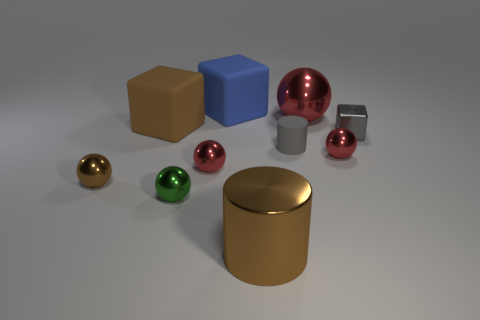What material is the green thing that is the same shape as the big red metallic thing?
Provide a succinct answer. Metal. There is a block that is both to the right of the green shiny thing and in front of the big blue rubber block; what is its color?
Offer a very short reply. Gray. The matte cylinder is what color?
Offer a very short reply. Gray. There is a cube that is the same color as the matte cylinder; what is it made of?
Your answer should be very brief. Metal. Is there another blue rubber thing of the same shape as the big blue thing?
Your answer should be compact. No. What size is the brown metal thing in front of the brown metallic ball?
Ensure brevity in your answer.  Large. There is a sphere that is the same size as the blue block; what material is it?
Your response must be concise. Metal. Is the number of rubber objects greater than the number of big shiny balls?
Your answer should be compact. Yes. What is the size of the brown object behind the small red shiny object right of the large red thing?
Offer a terse response. Large. There is a brown object that is the same size as the metal cylinder; what is its shape?
Ensure brevity in your answer.  Cube. 